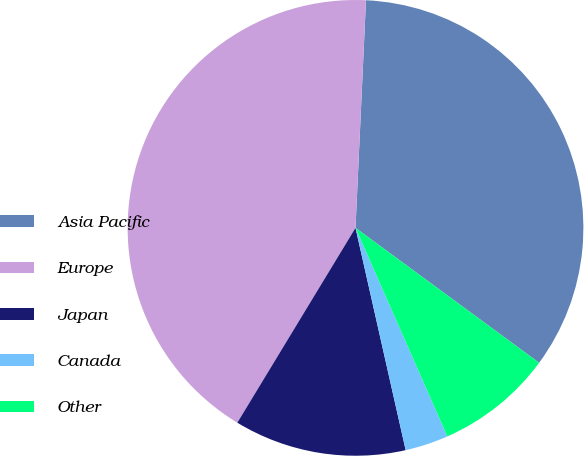Convert chart. <chart><loc_0><loc_0><loc_500><loc_500><pie_chart><fcel>Asia Pacific<fcel>Europe<fcel>Japan<fcel>Canada<fcel>Other<nl><fcel>34.35%<fcel>42.05%<fcel>12.21%<fcel>3.07%<fcel>8.31%<nl></chart> 